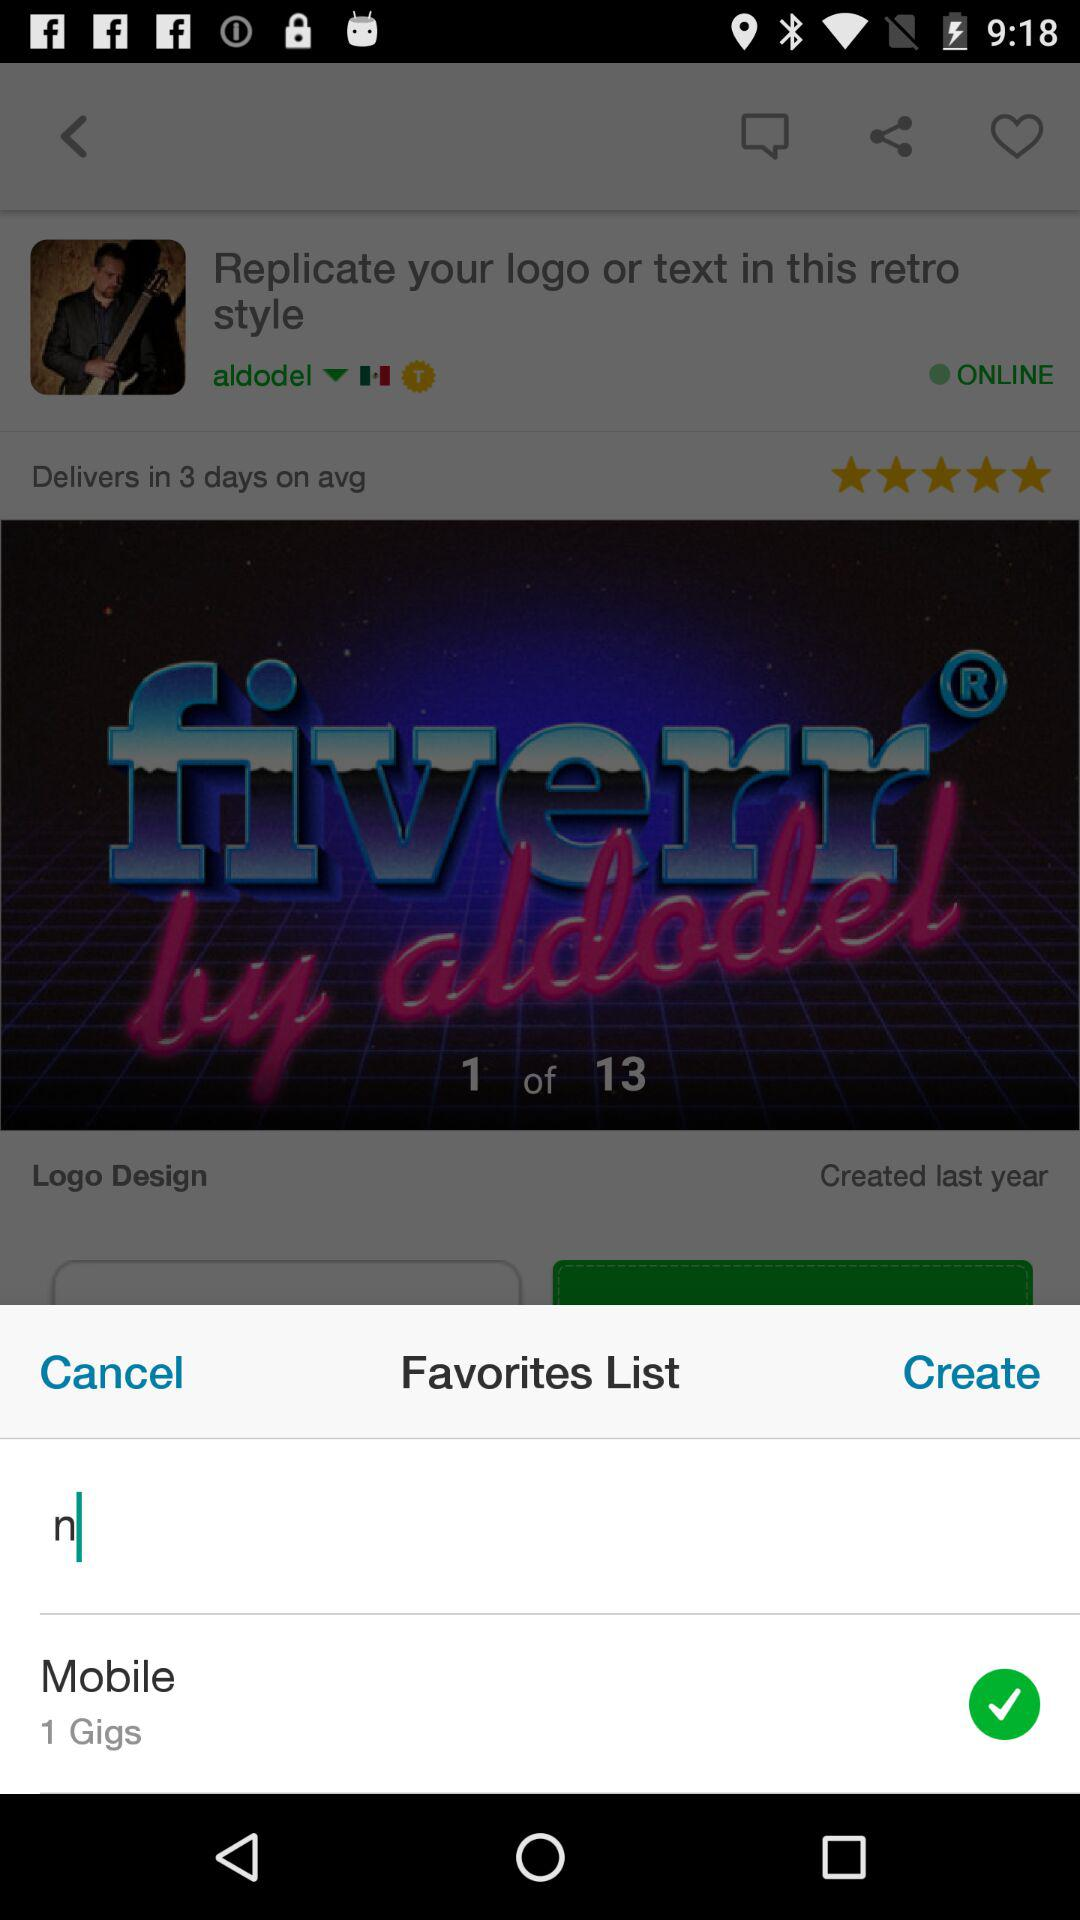What is the rating? The rating is 5 stars. 